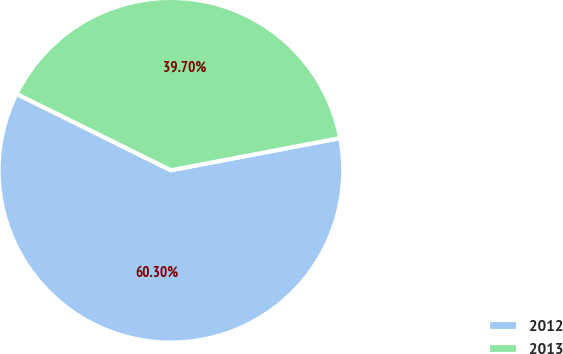Convert chart. <chart><loc_0><loc_0><loc_500><loc_500><pie_chart><fcel>2012<fcel>2013<nl><fcel>60.3%<fcel>39.7%<nl></chart> 